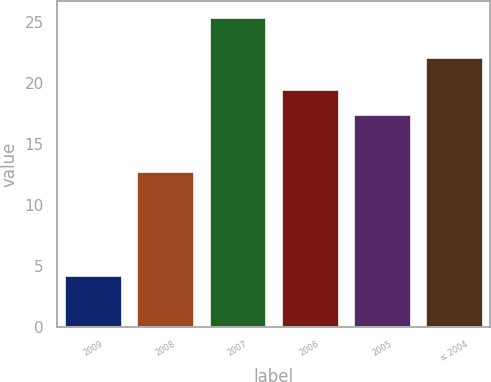Convert chart. <chart><loc_0><loc_0><loc_500><loc_500><bar_chart><fcel>2009<fcel>2008<fcel>2007<fcel>2006<fcel>2005<fcel>≤ 2004<nl><fcel>4.2<fcel>12.8<fcel>25.4<fcel>19.52<fcel>17.4<fcel>22.1<nl></chart> 